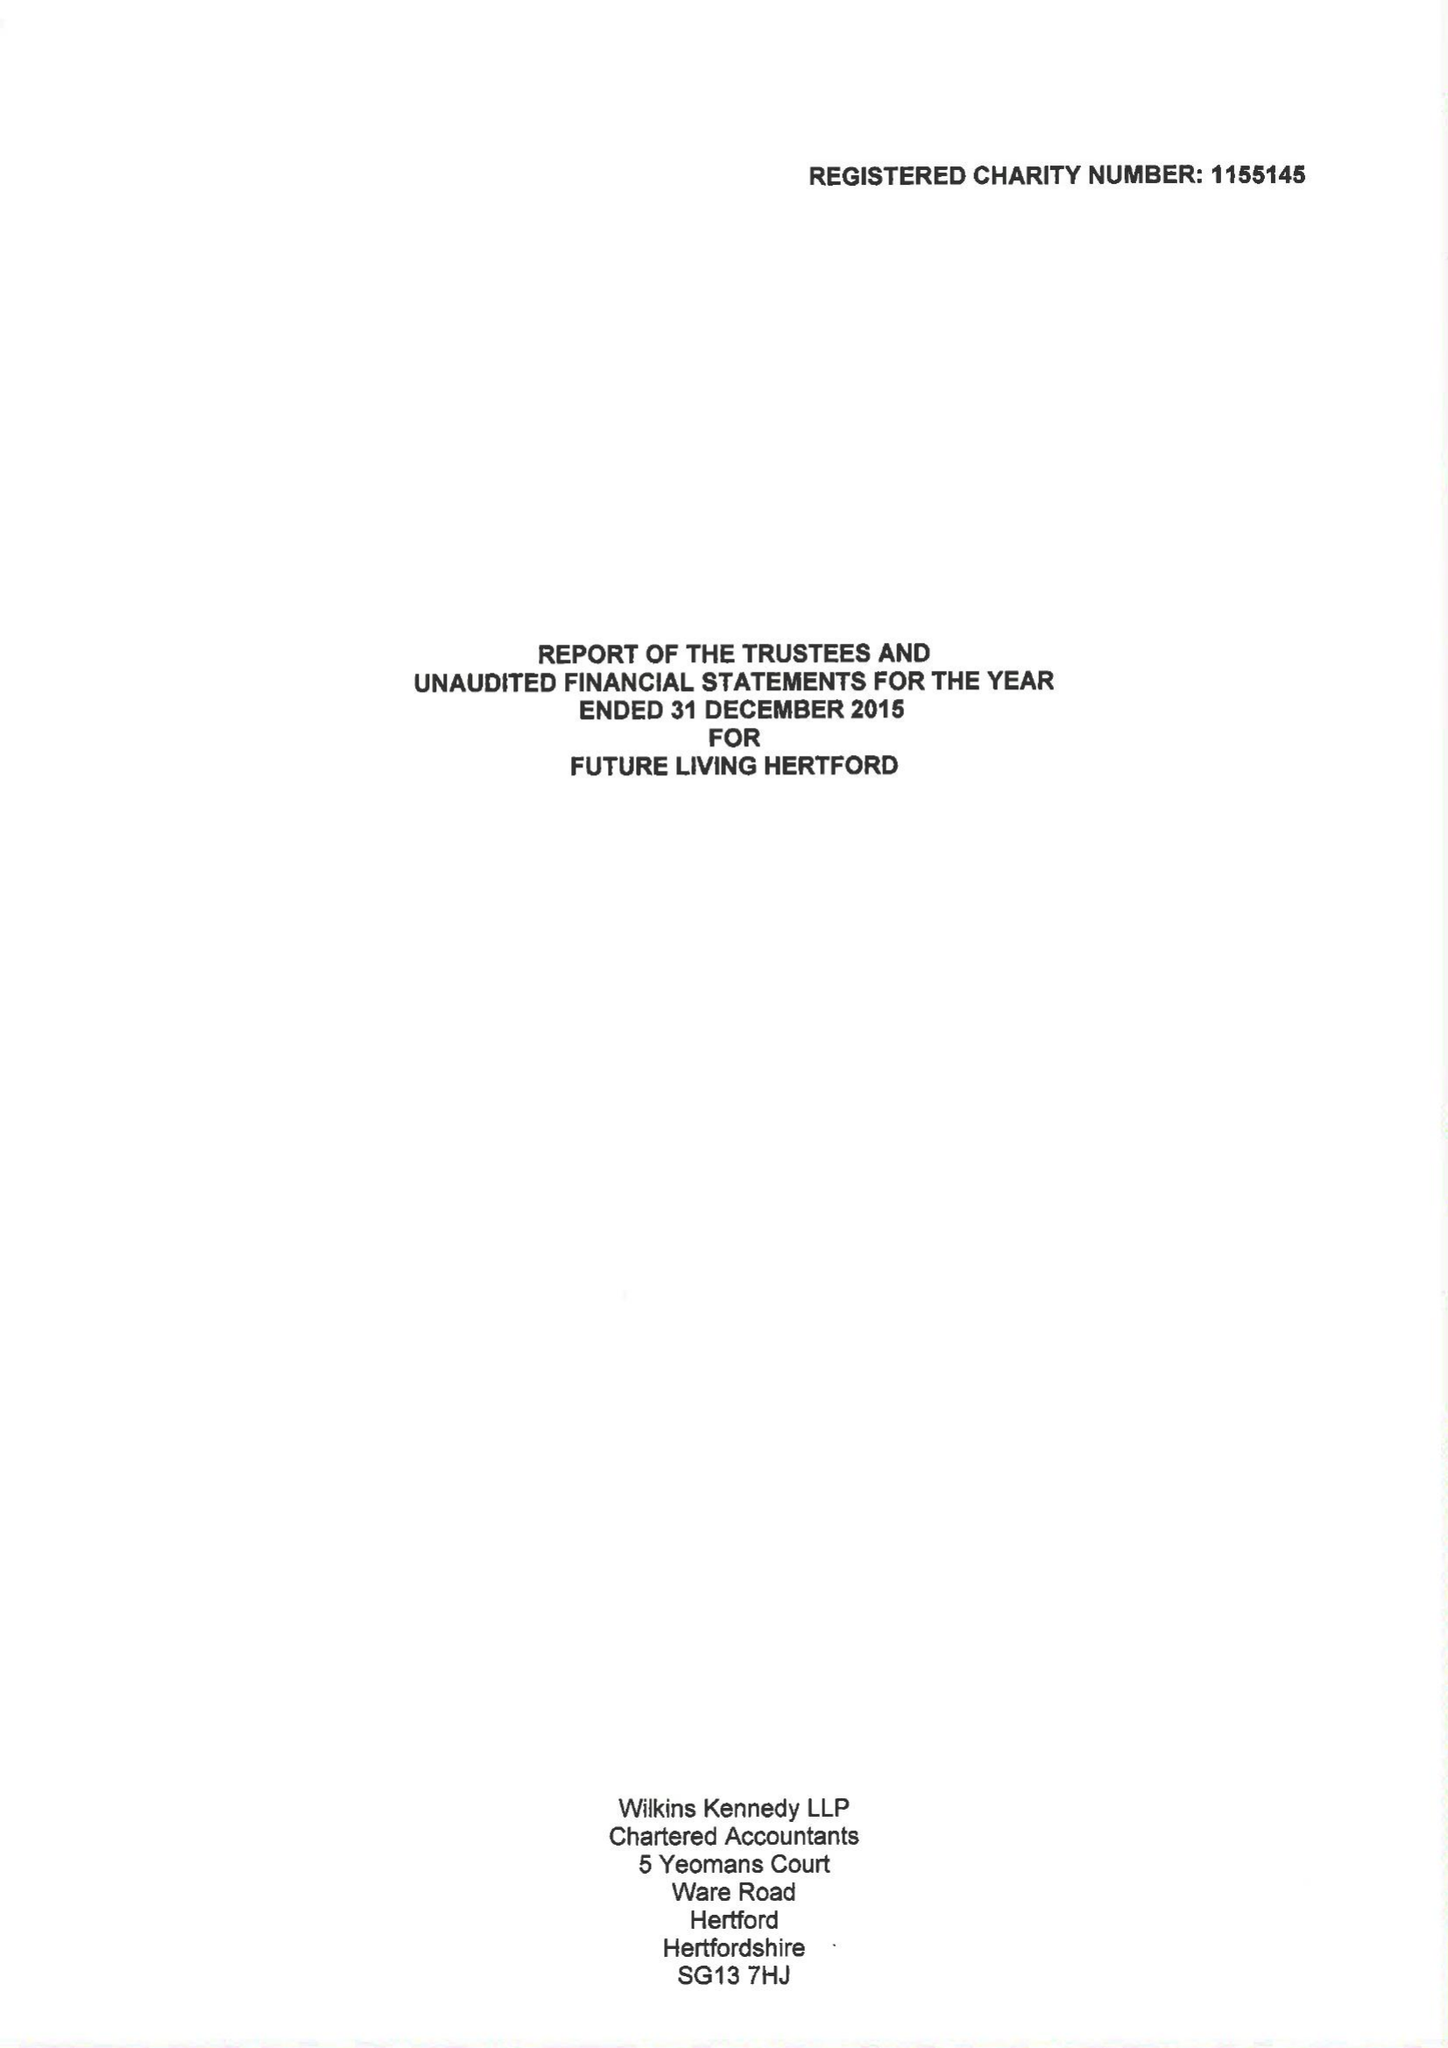What is the value for the charity_number?
Answer the question using a single word or phrase. 1155145 